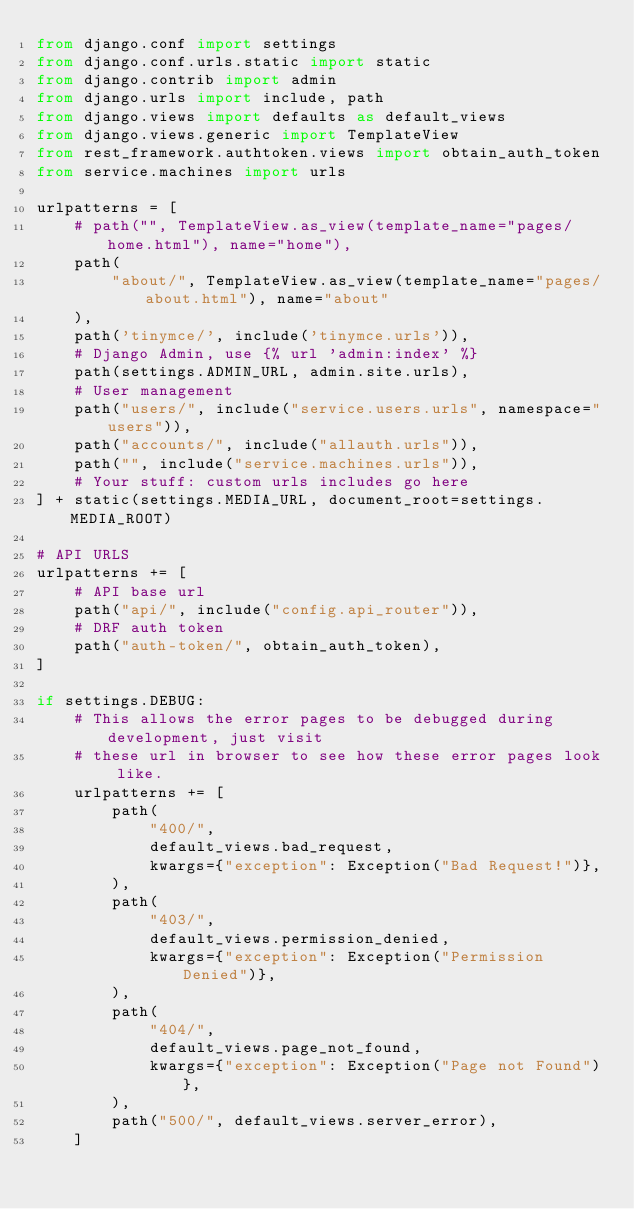Convert code to text. <code><loc_0><loc_0><loc_500><loc_500><_Python_>from django.conf import settings
from django.conf.urls.static import static
from django.contrib import admin
from django.urls import include, path
from django.views import defaults as default_views
from django.views.generic import TemplateView
from rest_framework.authtoken.views import obtain_auth_token
from service.machines import urls

urlpatterns = [
    # path("", TemplateView.as_view(template_name="pages/home.html"), name="home"),
    path(
        "about/", TemplateView.as_view(template_name="pages/about.html"), name="about"
    ),
    path('tinymce/', include('tinymce.urls')),
    # Django Admin, use {% url 'admin:index' %}
    path(settings.ADMIN_URL, admin.site.urls),
    # User management
    path("users/", include("service.users.urls", namespace="users")),
    path("accounts/", include("allauth.urls")),
    path("", include("service.machines.urls")),
    # Your stuff: custom urls includes go here
] + static(settings.MEDIA_URL, document_root=settings.MEDIA_ROOT)

# API URLS
urlpatterns += [
    # API base url
    path("api/", include("config.api_router")),
    # DRF auth token
    path("auth-token/", obtain_auth_token),
]

if settings.DEBUG:
    # This allows the error pages to be debugged during development, just visit
    # these url in browser to see how these error pages look like.
    urlpatterns += [
        path(
            "400/",
            default_views.bad_request,
            kwargs={"exception": Exception("Bad Request!")},
        ),
        path(
            "403/",
            default_views.permission_denied,
            kwargs={"exception": Exception("Permission Denied")},
        ),
        path(
            "404/",
            default_views.page_not_found,
            kwargs={"exception": Exception("Page not Found")},
        ),
        path("500/", default_views.server_error),
    ]
</code> 